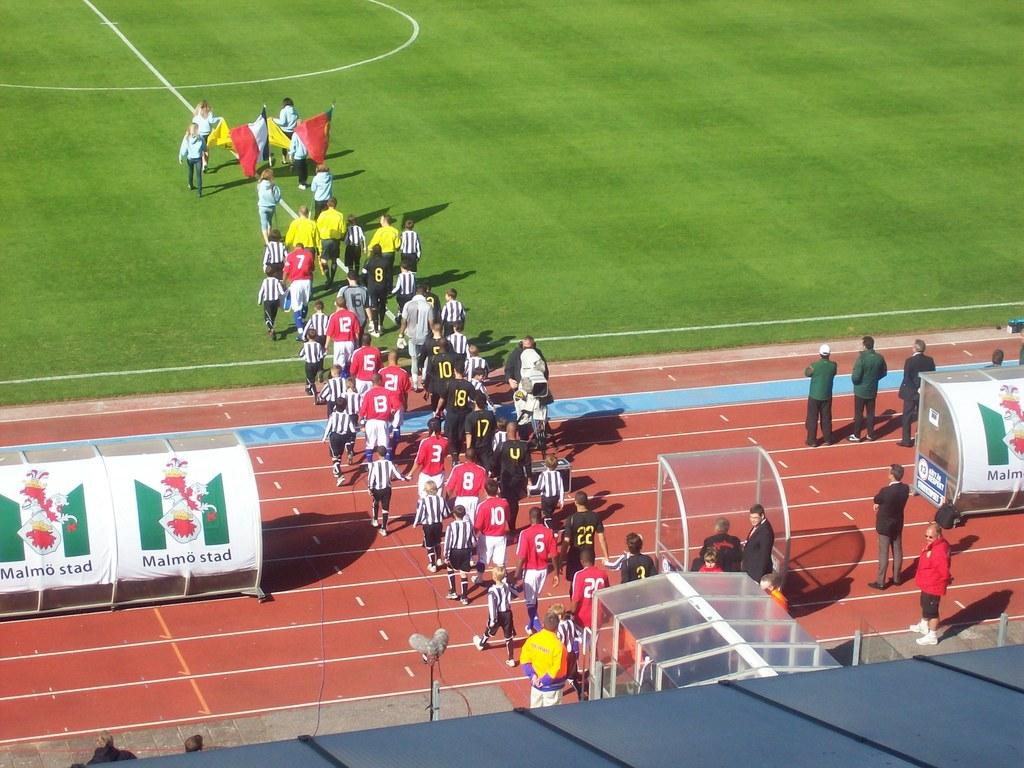What is happening in the image involving the group of people? The people in the image are walking. What are the people wearing? The people are wearing multi-color dresses. What can be seen in the background of the image? There is a stadium in the image. What else is present in the image besides the people and the stadium? There are banners attached to poles in the image. How many ladybugs can be seen crawling on the cloth in the image? There are no ladybugs or cloth present in the image. What type of destruction is visible in the image? There is no destruction present in the image; it features a group of people walking, wearing multi-color dresses, and a stadium in the background. 